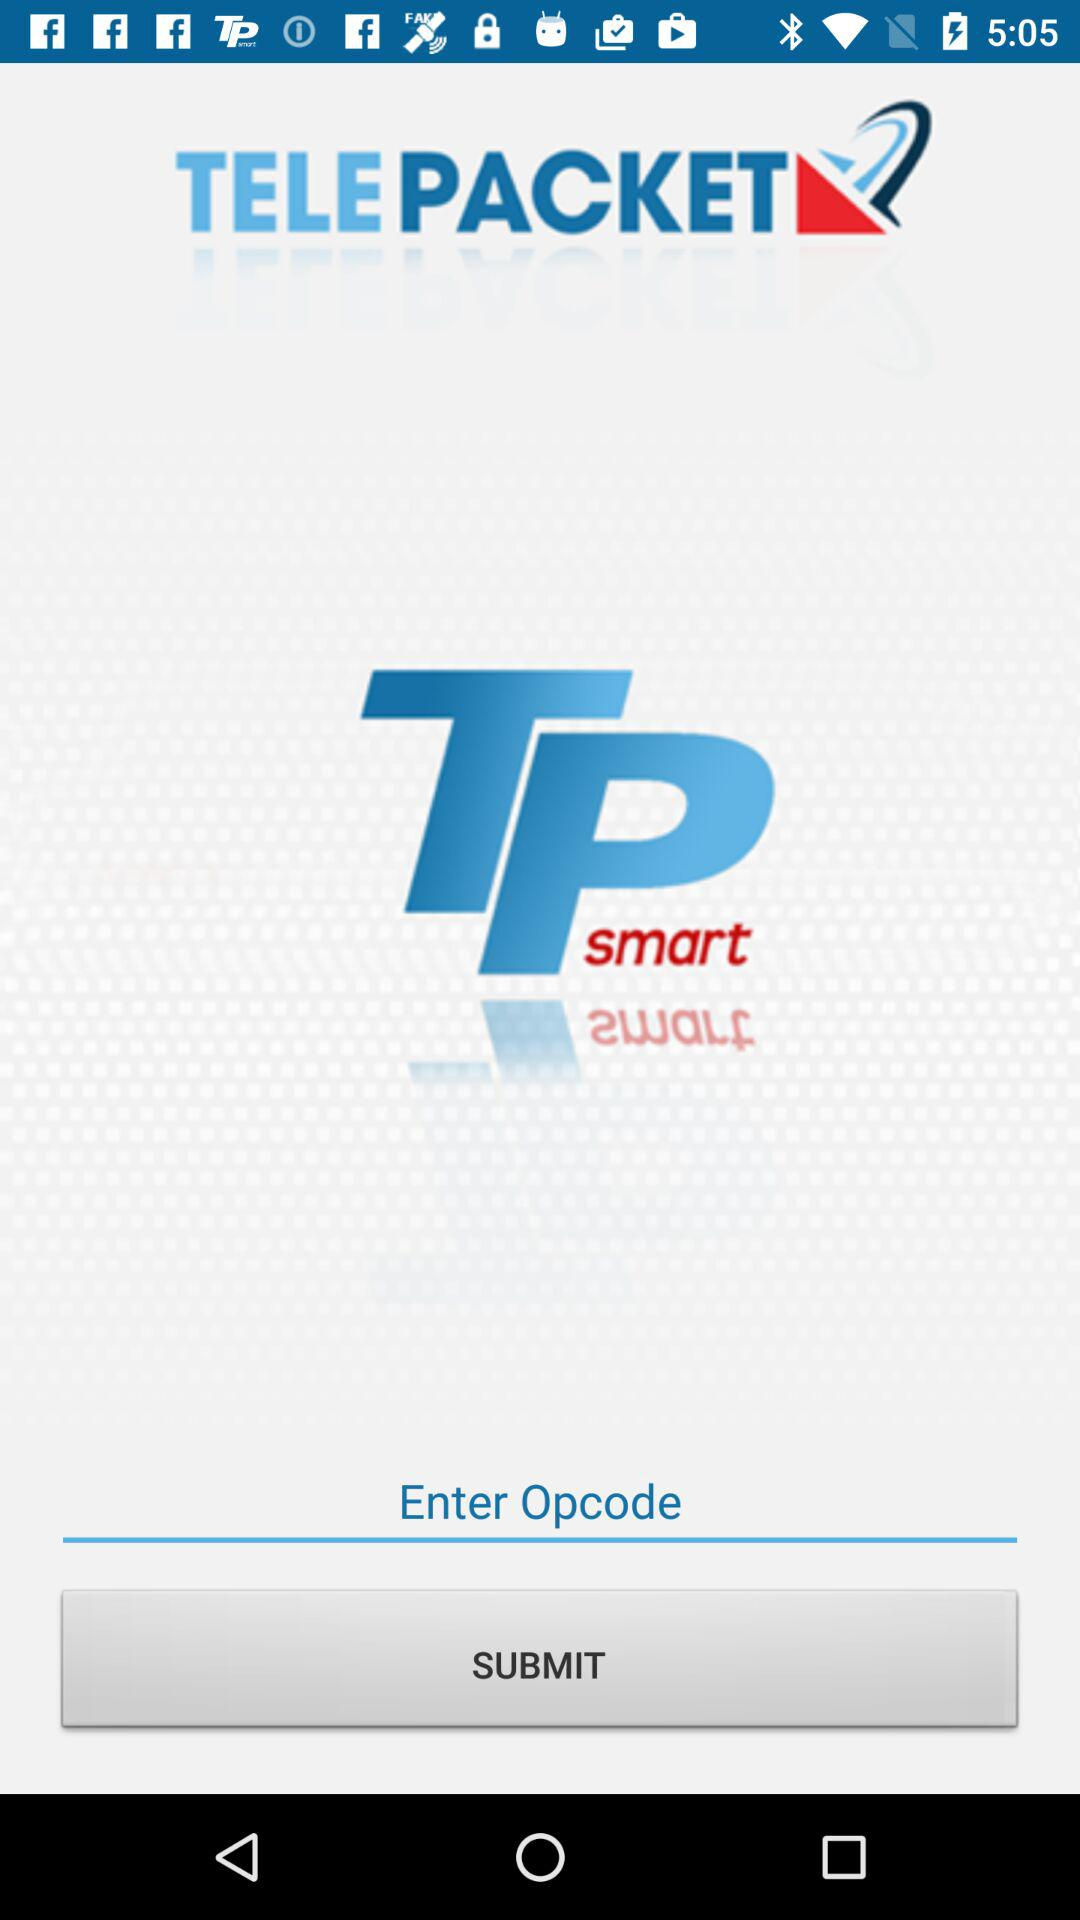What is the name of the application? The name of the application is "TELEPACKET". 